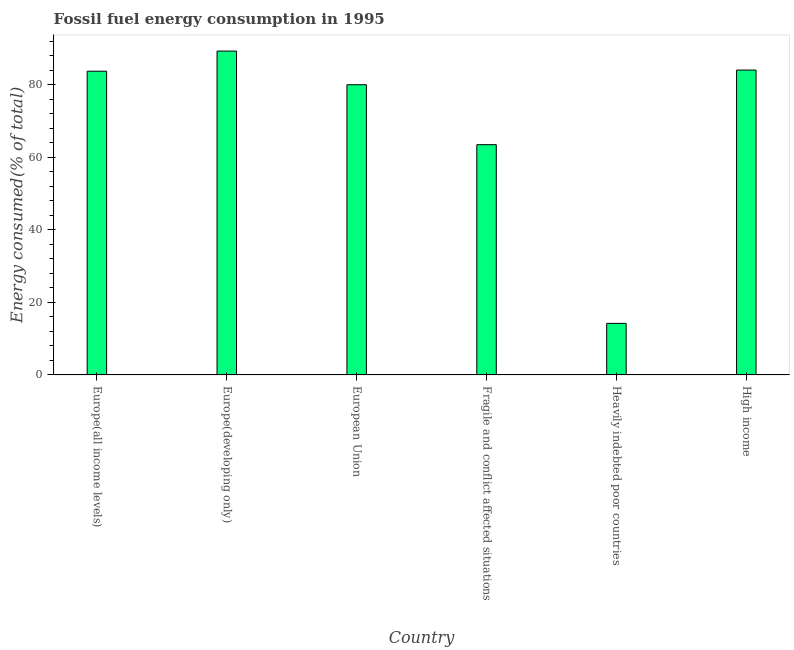What is the title of the graph?
Ensure brevity in your answer.  Fossil fuel energy consumption in 1995. What is the label or title of the Y-axis?
Provide a succinct answer. Energy consumed(% of total). What is the fossil fuel energy consumption in European Union?
Give a very brief answer. 80.07. Across all countries, what is the maximum fossil fuel energy consumption?
Provide a short and direct response. 89.36. Across all countries, what is the minimum fossil fuel energy consumption?
Keep it short and to the point. 14.22. In which country was the fossil fuel energy consumption maximum?
Your answer should be very brief. Europe(developing only). In which country was the fossil fuel energy consumption minimum?
Make the answer very short. Heavily indebted poor countries. What is the sum of the fossil fuel energy consumption?
Offer a terse response. 415.1. What is the difference between the fossil fuel energy consumption in Heavily indebted poor countries and High income?
Your answer should be very brief. -69.89. What is the average fossil fuel energy consumption per country?
Your answer should be very brief. 69.18. What is the median fossil fuel energy consumption?
Your response must be concise. 81.94. In how many countries, is the fossil fuel energy consumption greater than 72 %?
Your answer should be compact. 4. What is the ratio of the fossil fuel energy consumption in Europe(all income levels) to that in High income?
Provide a succinct answer. 1. What is the difference between the highest and the second highest fossil fuel energy consumption?
Keep it short and to the point. 5.24. What is the difference between the highest and the lowest fossil fuel energy consumption?
Your answer should be compact. 75.14. In how many countries, is the fossil fuel energy consumption greater than the average fossil fuel energy consumption taken over all countries?
Offer a very short reply. 4. How many bars are there?
Keep it short and to the point. 6. How many countries are there in the graph?
Ensure brevity in your answer.  6. What is the difference between two consecutive major ticks on the Y-axis?
Make the answer very short. 20. Are the values on the major ticks of Y-axis written in scientific E-notation?
Give a very brief answer. No. What is the Energy consumed(% of total) of Europe(all income levels)?
Offer a very short reply. 83.8. What is the Energy consumed(% of total) of Europe(developing only)?
Offer a terse response. 89.36. What is the Energy consumed(% of total) in European Union?
Your answer should be compact. 80.07. What is the Energy consumed(% of total) of Fragile and conflict affected situations?
Your answer should be compact. 63.53. What is the Energy consumed(% of total) in Heavily indebted poor countries?
Provide a short and direct response. 14.22. What is the Energy consumed(% of total) of High income?
Provide a succinct answer. 84.12. What is the difference between the Energy consumed(% of total) in Europe(all income levels) and Europe(developing only)?
Your answer should be compact. -5.56. What is the difference between the Energy consumed(% of total) in Europe(all income levels) and European Union?
Your answer should be compact. 3.73. What is the difference between the Energy consumed(% of total) in Europe(all income levels) and Fragile and conflict affected situations?
Offer a terse response. 20.27. What is the difference between the Energy consumed(% of total) in Europe(all income levels) and Heavily indebted poor countries?
Your answer should be very brief. 69.58. What is the difference between the Energy consumed(% of total) in Europe(all income levels) and High income?
Ensure brevity in your answer.  -0.31. What is the difference between the Energy consumed(% of total) in Europe(developing only) and European Union?
Make the answer very short. 9.29. What is the difference between the Energy consumed(% of total) in Europe(developing only) and Fragile and conflict affected situations?
Your response must be concise. 25.83. What is the difference between the Energy consumed(% of total) in Europe(developing only) and Heavily indebted poor countries?
Your answer should be compact. 75.14. What is the difference between the Energy consumed(% of total) in Europe(developing only) and High income?
Your answer should be very brief. 5.24. What is the difference between the Energy consumed(% of total) in European Union and Fragile and conflict affected situations?
Make the answer very short. 16.55. What is the difference between the Energy consumed(% of total) in European Union and Heavily indebted poor countries?
Ensure brevity in your answer.  65.85. What is the difference between the Energy consumed(% of total) in European Union and High income?
Provide a succinct answer. -4.04. What is the difference between the Energy consumed(% of total) in Fragile and conflict affected situations and Heavily indebted poor countries?
Offer a terse response. 49.3. What is the difference between the Energy consumed(% of total) in Fragile and conflict affected situations and High income?
Provide a succinct answer. -20.59. What is the difference between the Energy consumed(% of total) in Heavily indebted poor countries and High income?
Make the answer very short. -69.89. What is the ratio of the Energy consumed(% of total) in Europe(all income levels) to that in Europe(developing only)?
Your answer should be compact. 0.94. What is the ratio of the Energy consumed(% of total) in Europe(all income levels) to that in European Union?
Your answer should be compact. 1.05. What is the ratio of the Energy consumed(% of total) in Europe(all income levels) to that in Fragile and conflict affected situations?
Provide a short and direct response. 1.32. What is the ratio of the Energy consumed(% of total) in Europe(all income levels) to that in Heavily indebted poor countries?
Your response must be concise. 5.89. What is the ratio of the Energy consumed(% of total) in Europe(all income levels) to that in High income?
Keep it short and to the point. 1. What is the ratio of the Energy consumed(% of total) in Europe(developing only) to that in European Union?
Ensure brevity in your answer.  1.12. What is the ratio of the Energy consumed(% of total) in Europe(developing only) to that in Fragile and conflict affected situations?
Your response must be concise. 1.41. What is the ratio of the Energy consumed(% of total) in Europe(developing only) to that in Heavily indebted poor countries?
Offer a terse response. 6.28. What is the ratio of the Energy consumed(% of total) in Europe(developing only) to that in High income?
Offer a very short reply. 1.06. What is the ratio of the Energy consumed(% of total) in European Union to that in Fragile and conflict affected situations?
Offer a very short reply. 1.26. What is the ratio of the Energy consumed(% of total) in European Union to that in Heavily indebted poor countries?
Offer a very short reply. 5.63. What is the ratio of the Energy consumed(% of total) in Fragile and conflict affected situations to that in Heavily indebted poor countries?
Make the answer very short. 4.47. What is the ratio of the Energy consumed(% of total) in Fragile and conflict affected situations to that in High income?
Provide a succinct answer. 0.76. What is the ratio of the Energy consumed(% of total) in Heavily indebted poor countries to that in High income?
Your answer should be very brief. 0.17. 